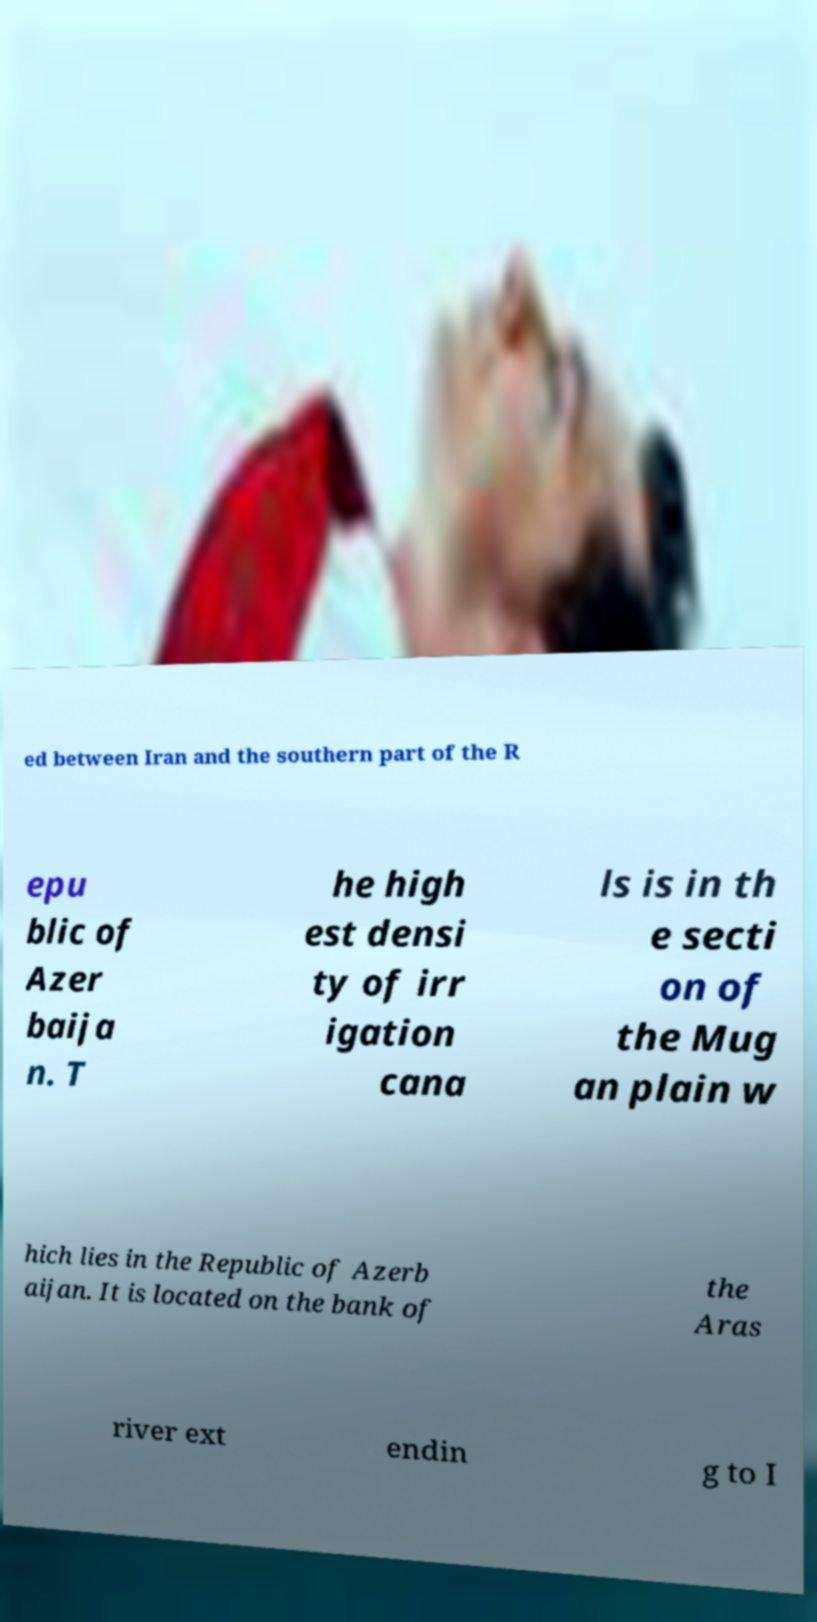For documentation purposes, I need the text within this image transcribed. Could you provide that? ed between Iran and the southern part of the R epu blic of Azer baija n. T he high est densi ty of irr igation cana ls is in th e secti on of the Mug an plain w hich lies in the Republic of Azerb aijan. It is located on the bank of the Aras river ext endin g to I 